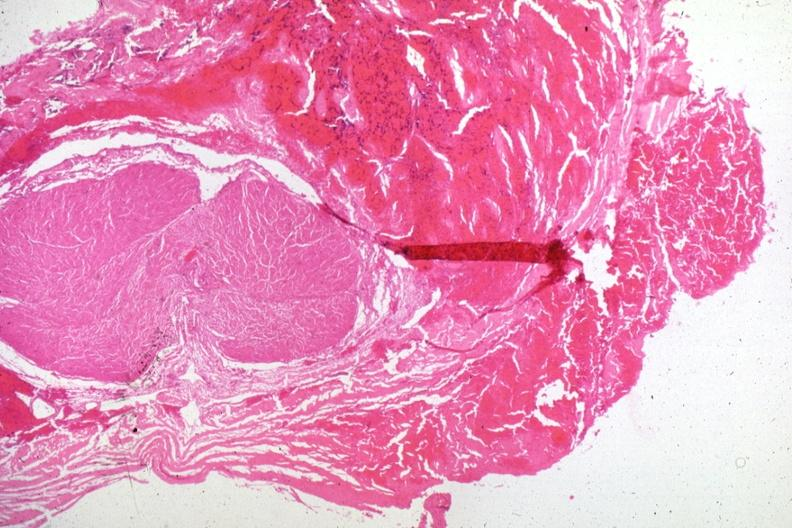s pituitary present?
Answer the question using a single word or phrase. Yes 